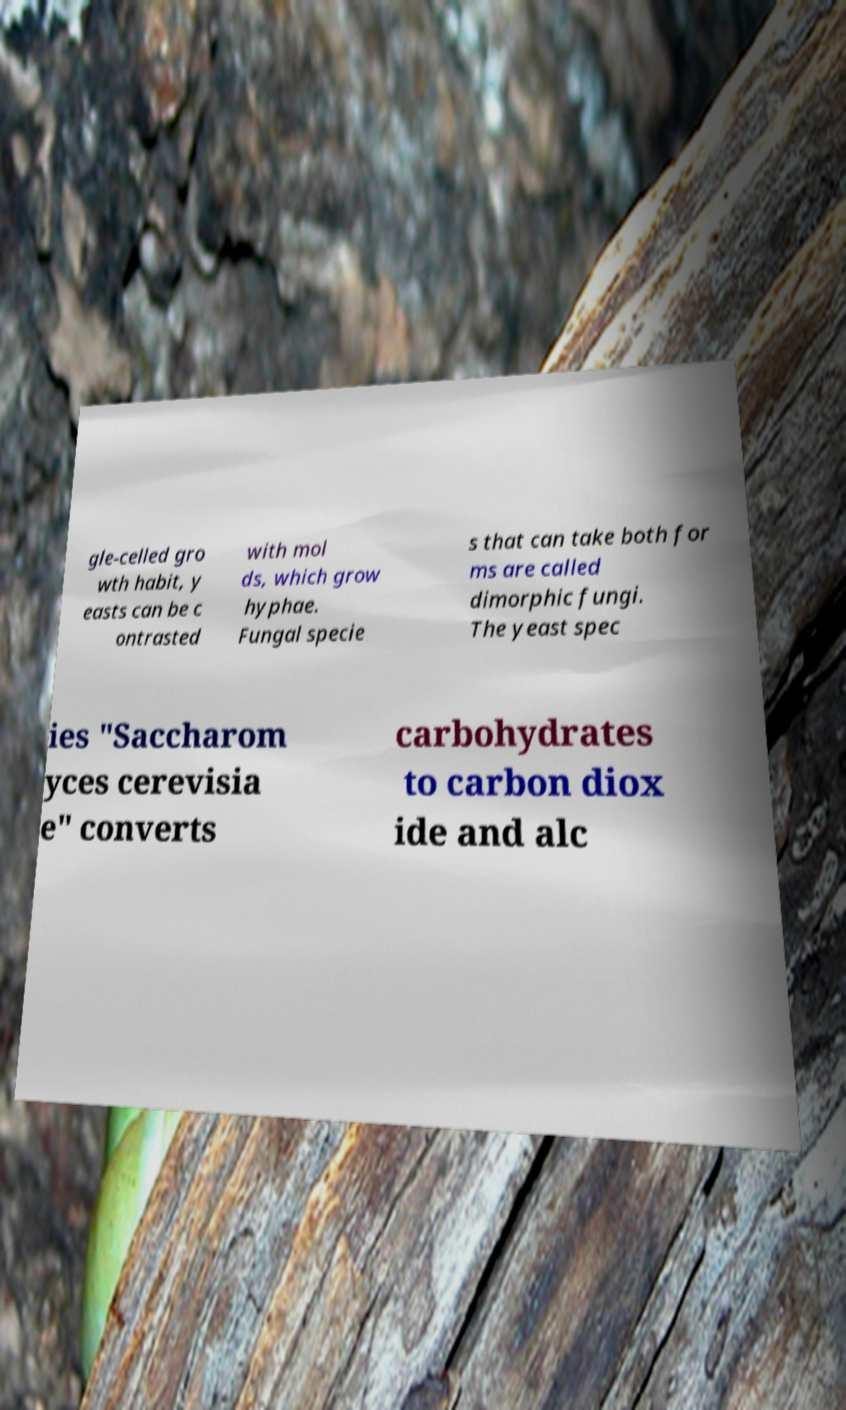What messages or text are displayed in this image? I need them in a readable, typed format. gle-celled gro wth habit, y easts can be c ontrasted with mol ds, which grow hyphae. Fungal specie s that can take both for ms are called dimorphic fungi. The yeast spec ies "Saccharom yces cerevisia e" converts carbohydrates to carbon diox ide and alc 